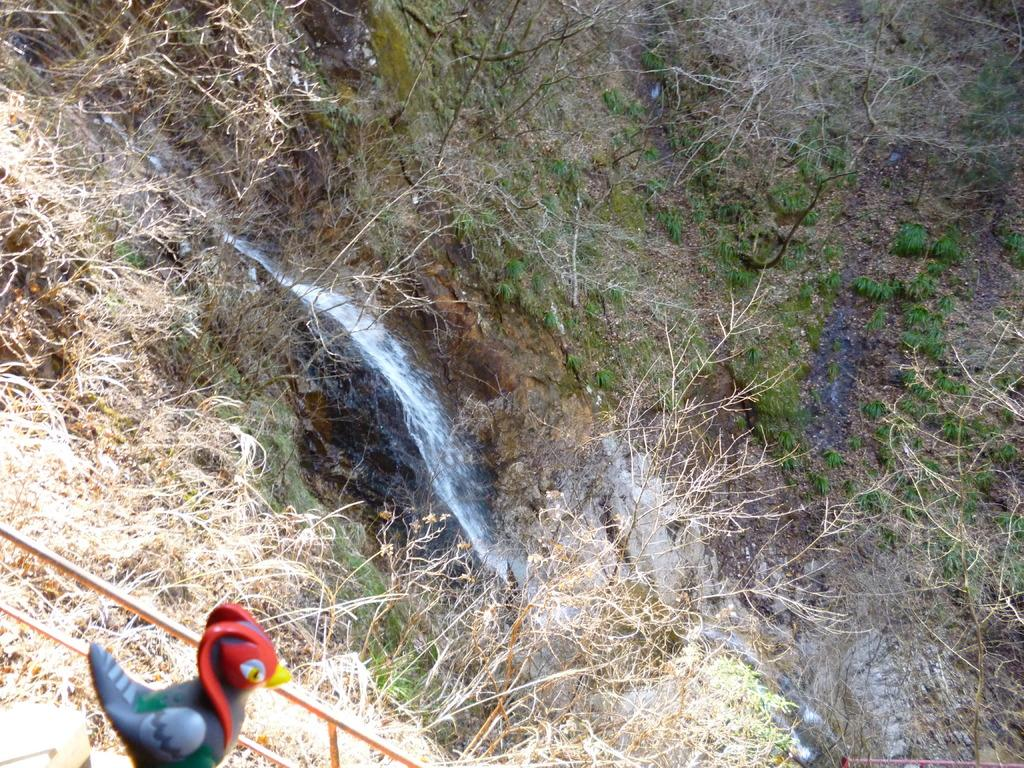What is the main feature in the middle of the image? There is a waterfall in the middle of the image. What type of natural elements can be seen in the image? There are trees in the image. Can you describe a specific object in the bottom left of the image? There is a toy that looks like a bird in the bottom left of the image. What type of structure is present in the image? There is a fence in the image. Where is the heart-shaped pizza being served from in the image? There is no heart-shaped pizza or any pizza present in the image. What type of throne can be seen in the image? There is no throne present in the image. 